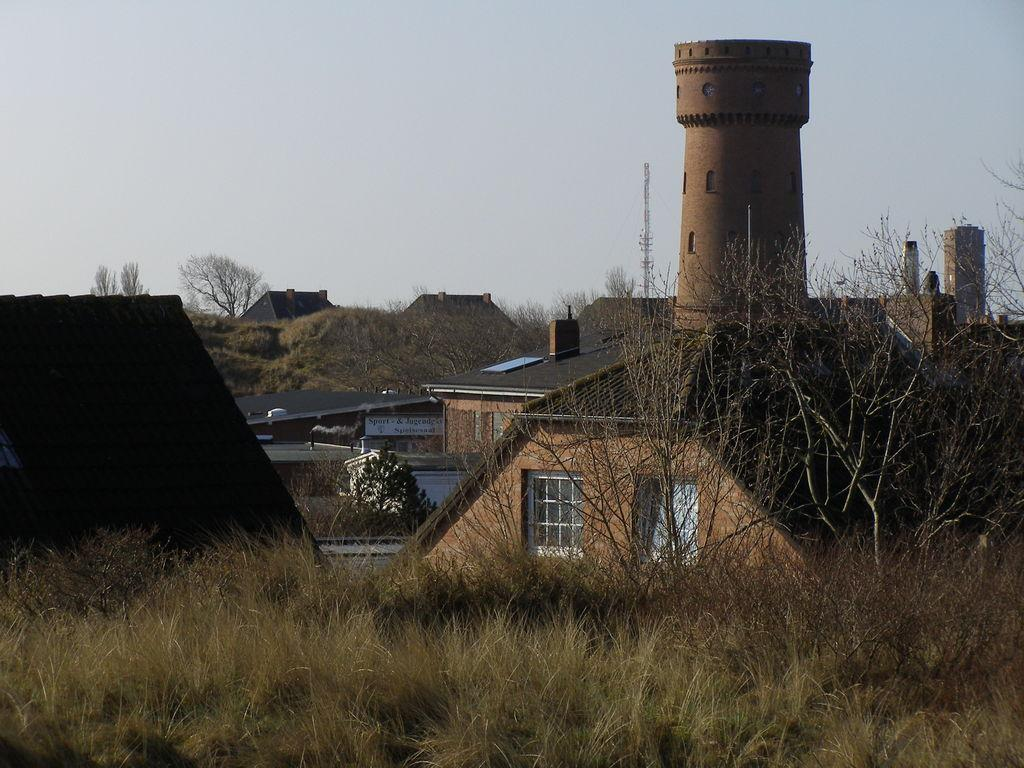What type of ground surface is visible in the image? There is grass on the ground in the image. What can be seen in the distance in the image? There are buildings, a tower, trees, and the sky visible in the background of the image. How many girls are participating in the protest in the image? There is no protest or girls present in the image. 